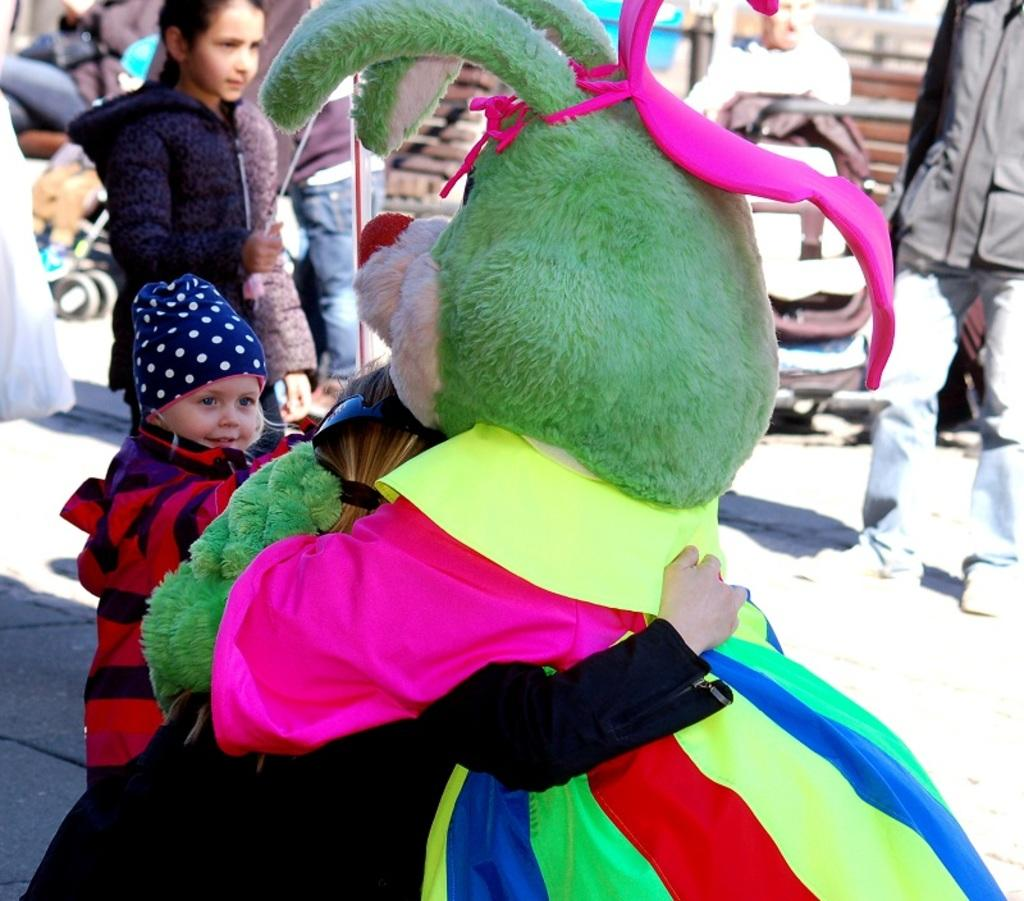Who is in the image? There is a person in the image. What is the person doing in the image? The person is hugging a clown. How many kids are in the image? There are two kids in the image. Where are the kids located in the image? The kids are standing on the left side of the image. What are the kids wearing in the image? The kids are wearing clothes. What type of brush is being used to touch the clown in the image? There is no brush or touching of the clown depicted in the image. 